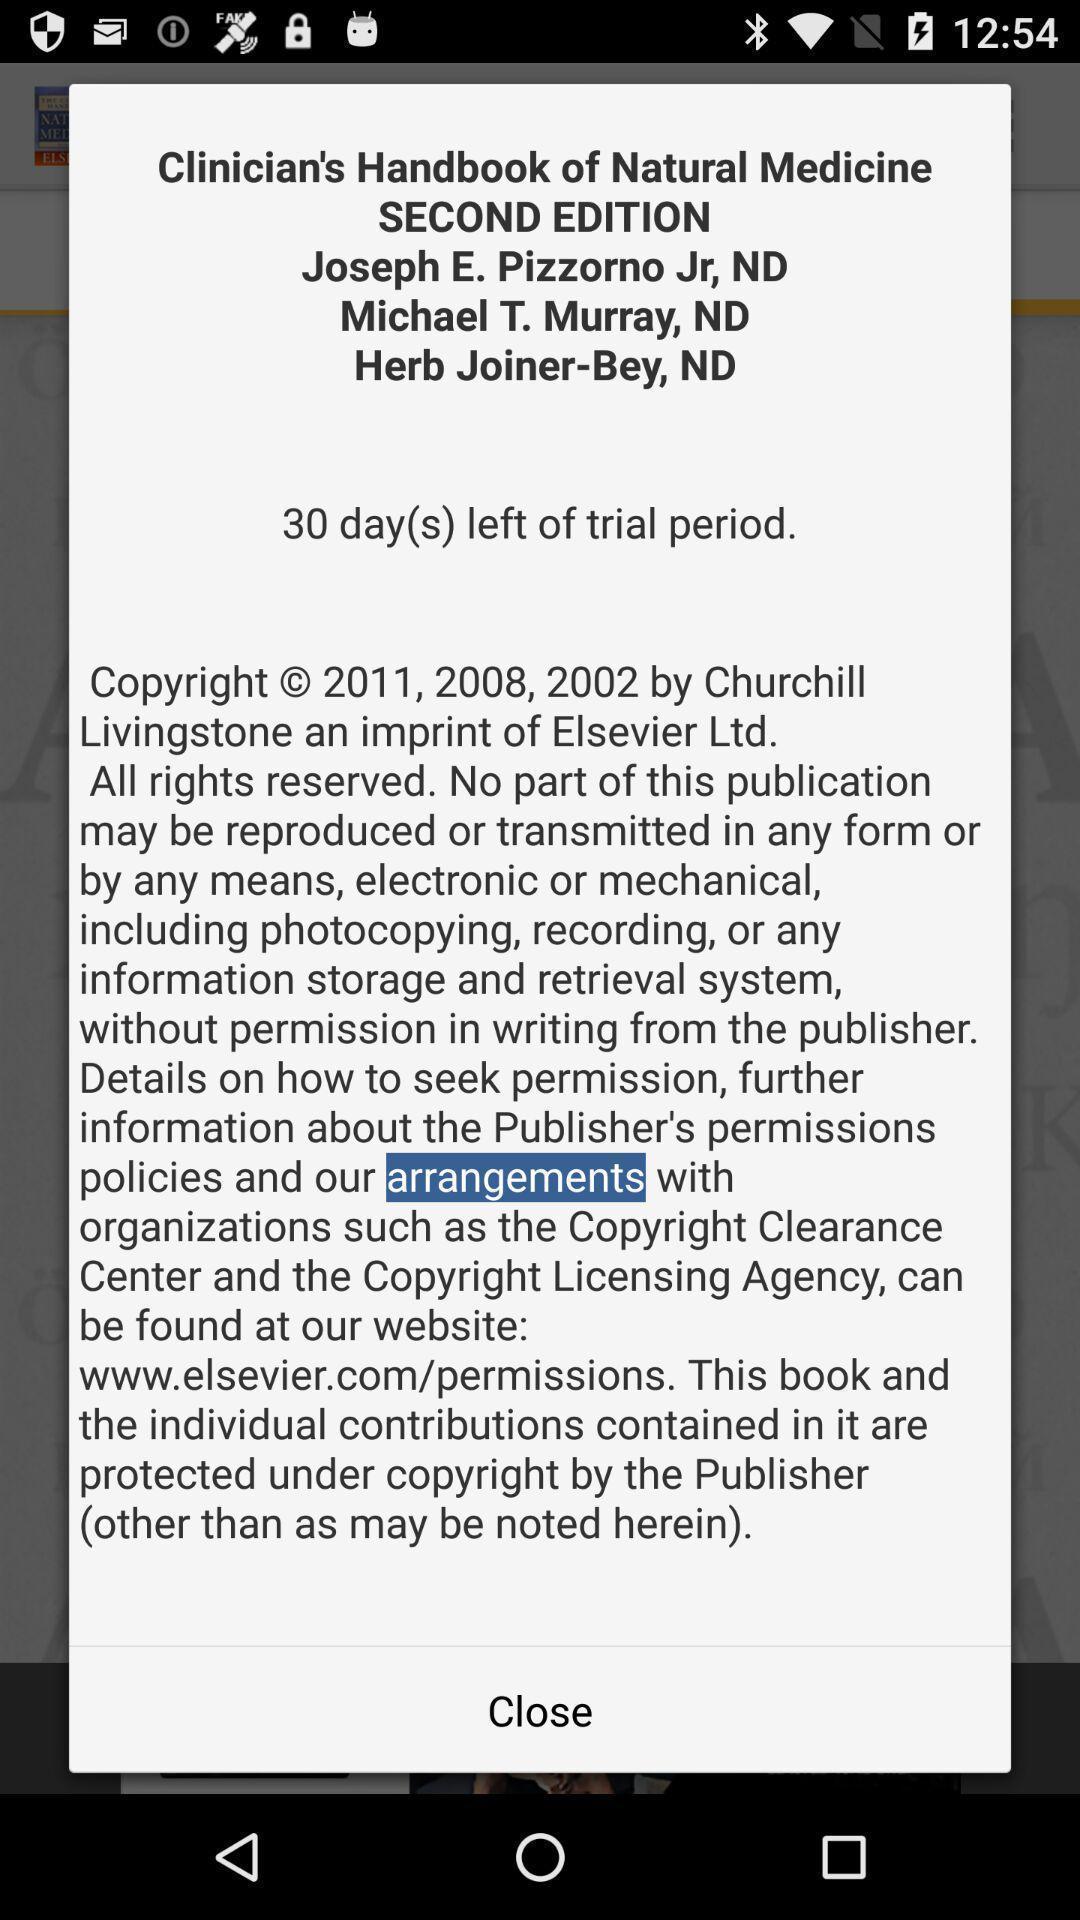Describe the key features of this screenshot. Popup of the information about medical app. 